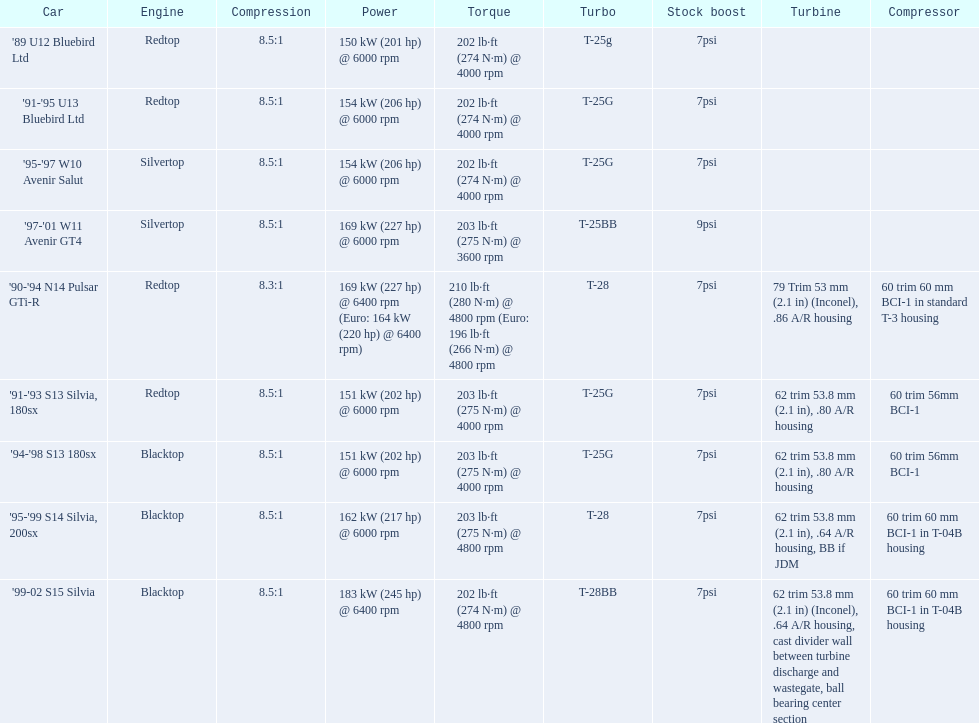Which cars list turbine details? '90-'94 N14 Pulsar GTi-R, '91-'93 S13 Silvia, 180sx, '94-'98 S13 180sx, '95-'99 S14 Silvia, 200sx, '99-02 S15 Silvia. Which of these hit their peak hp at the highest rpm? '90-'94 N14 Pulsar GTi-R, '99-02 S15 Silvia. Of those what is the compression of the only engine that isn't blacktop?? 8.3:1. 